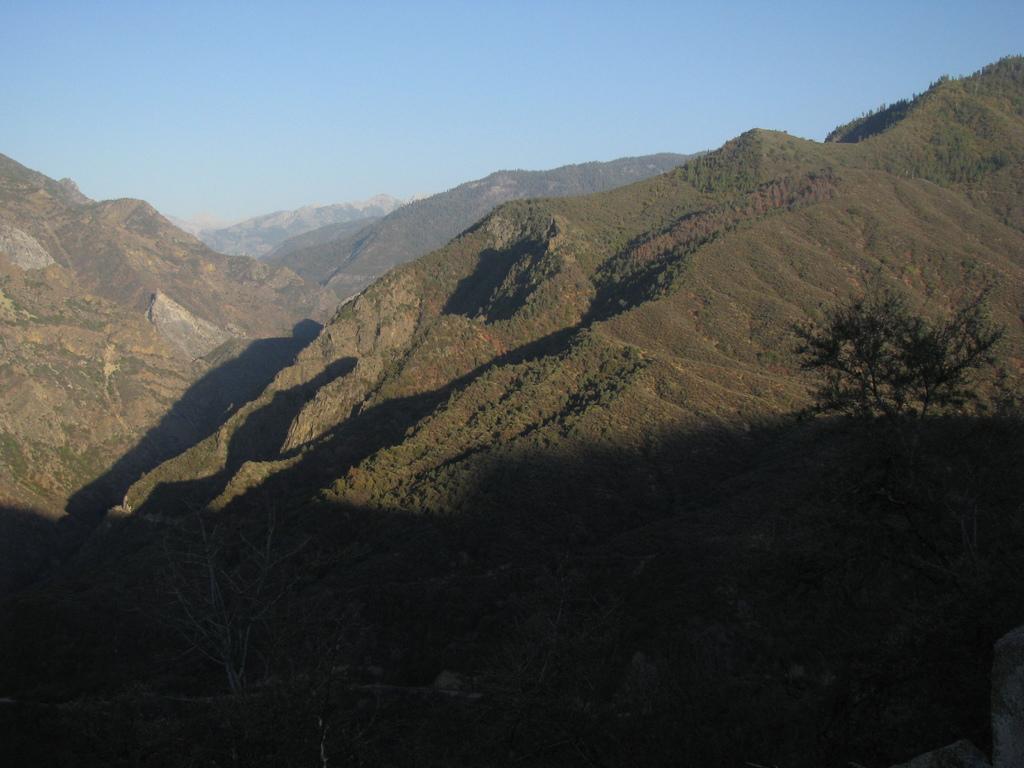Describe this image in one or two sentences. In the picture I can see trees, hills and the blue sky in the background. 